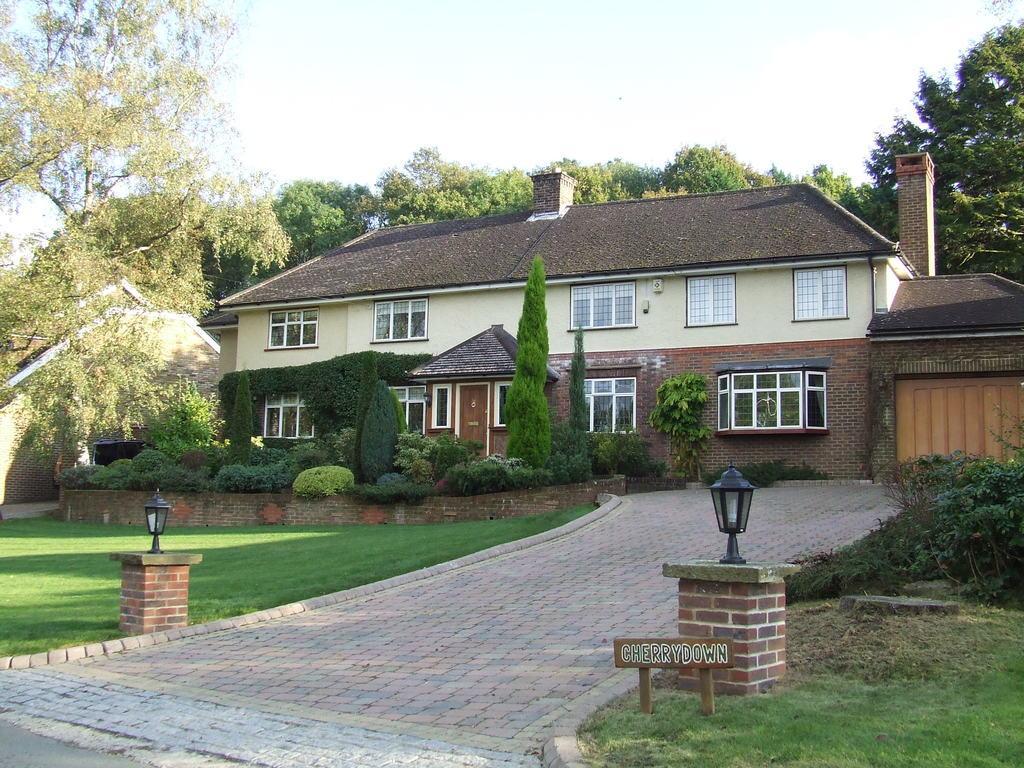Describe this image in one or two sentences. In this image we can see houses, trees, plants, grass, windows, door, pillars, lamps, path, and a board. In the background there is sky. 